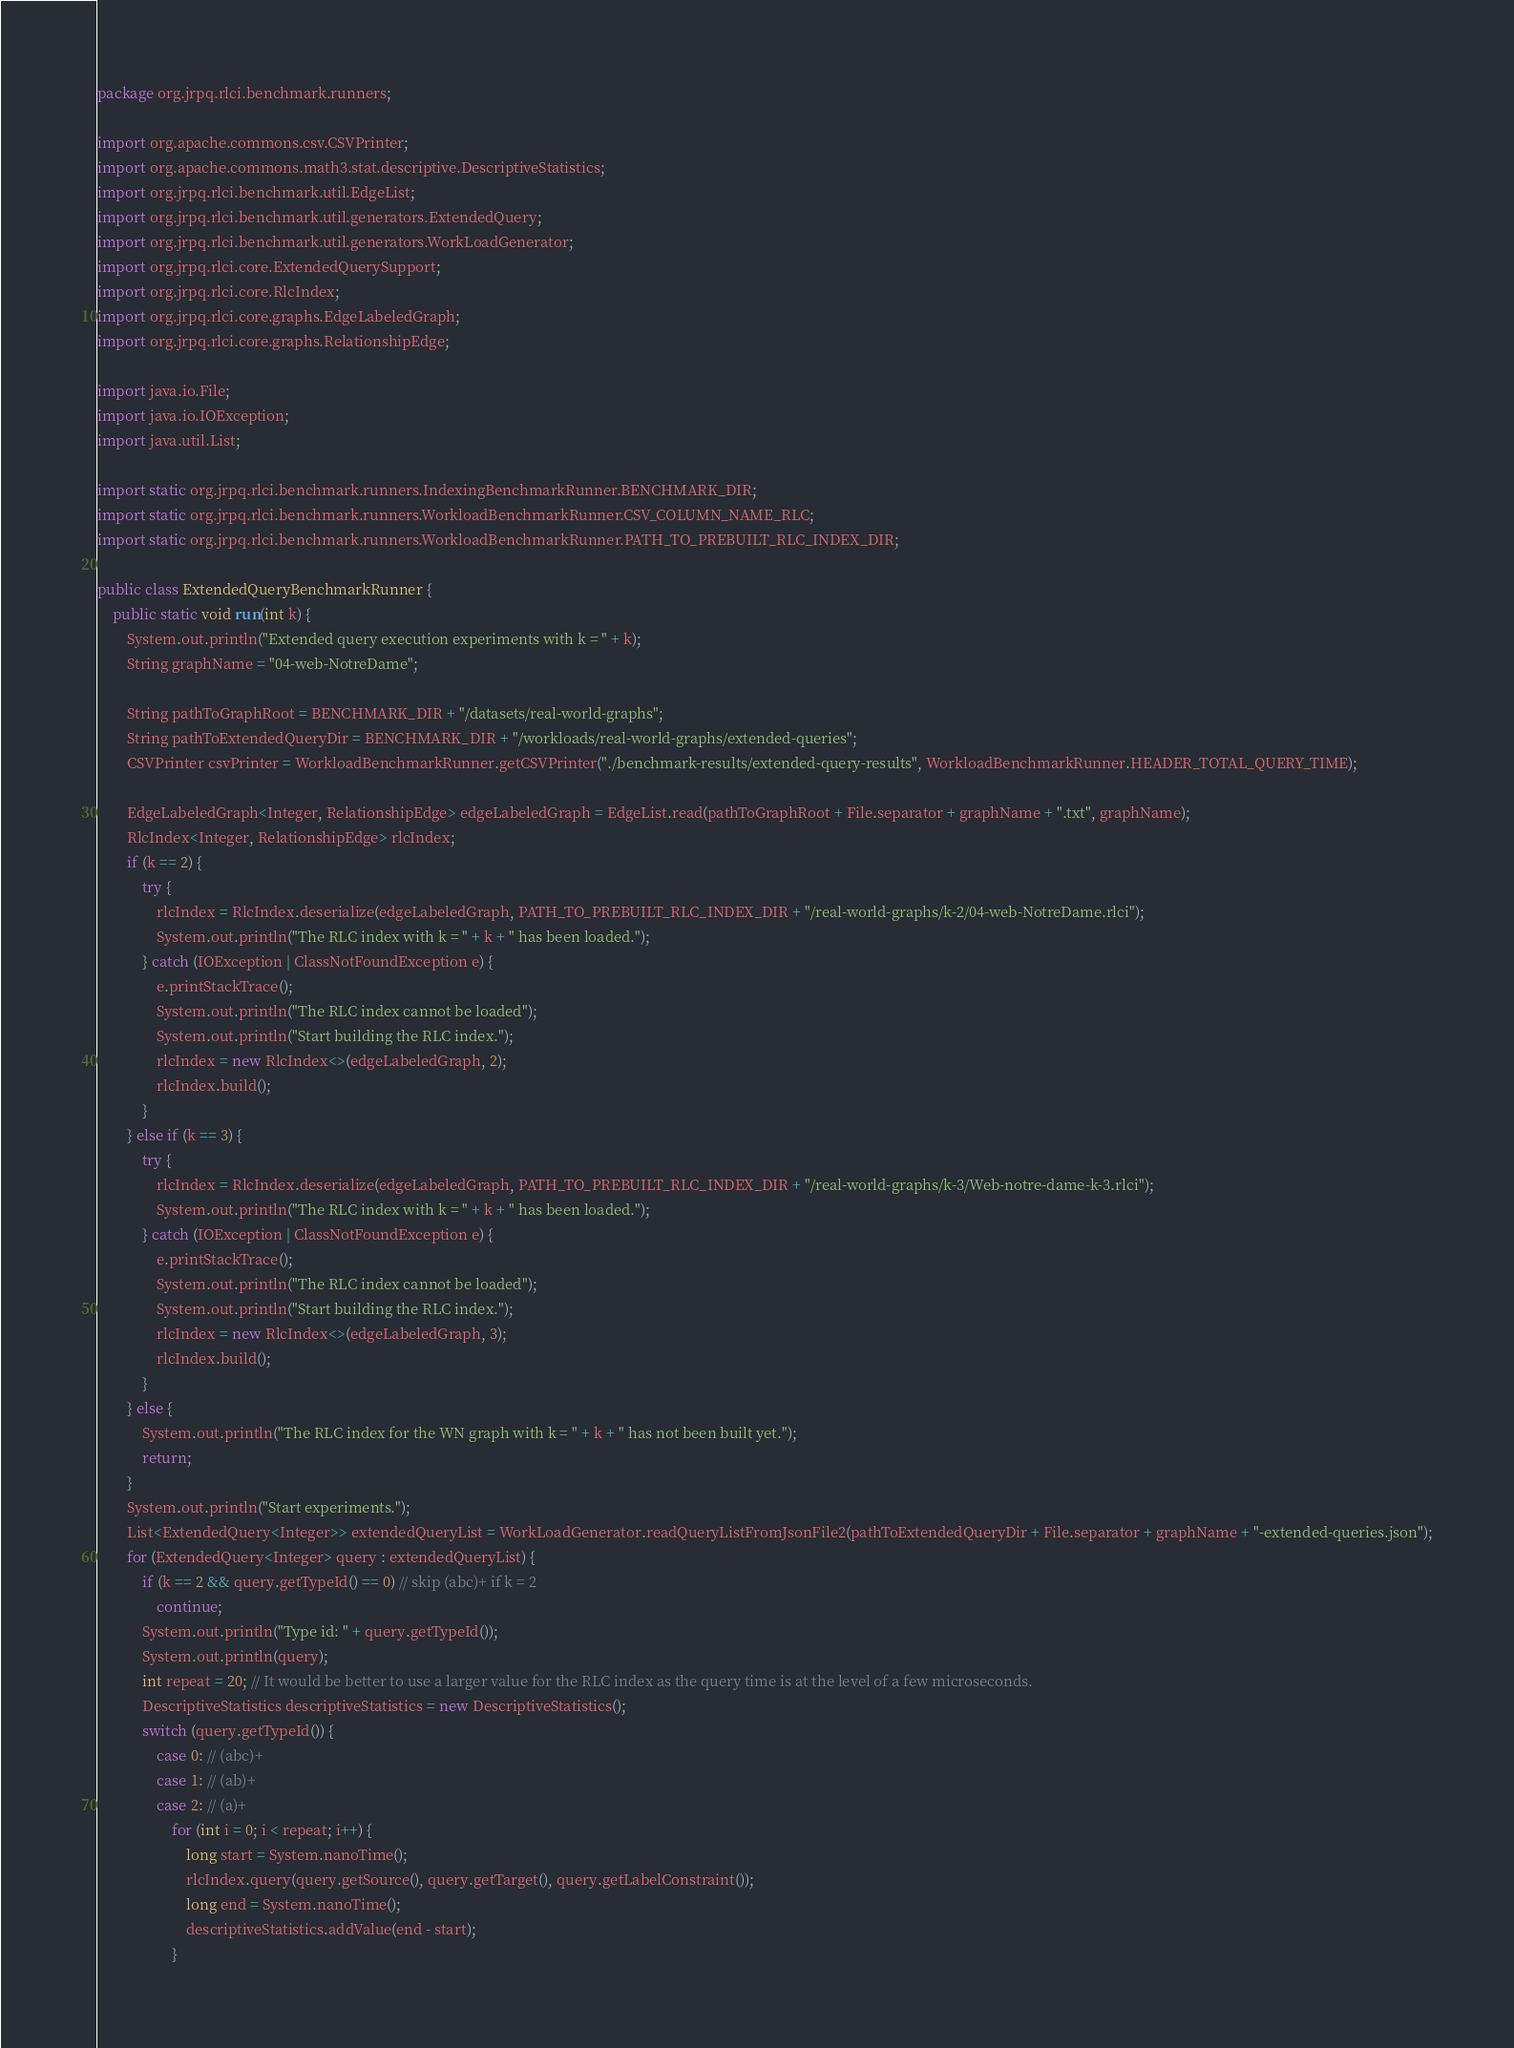<code> <loc_0><loc_0><loc_500><loc_500><_Java_>package org.jrpq.rlci.benchmark.runners;

import org.apache.commons.csv.CSVPrinter;
import org.apache.commons.math3.stat.descriptive.DescriptiveStatistics;
import org.jrpq.rlci.benchmark.util.EdgeList;
import org.jrpq.rlci.benchmark.util.generators.ExtendedQuery;
import org.jrpq.rlci.benchmark.util.generators.WorkLoadGenerator;
import org.jrpq.rlci.core.ExtendedQuerySupport;
import org.jrpq.rlci.core.RlcIndex;
import org.jrpq.rlci.core.graphs.EdgeLabeledGraph;
import org.jrpq.rlci.core.graphs.RelationshipEdge;

import java.io.File;
import java.io.IOException;
import java.util.List;

import static org.jrpq.rlci.benchmark.runners.IndexingBenchmarkRunner.BENCHMARK_DIR;
import static org.jrpq.rlci.benchmark.runners.WorkloadBenchmarkRunner.CSV_COLUMN_NAME_RLC;
import static org.jrpq.rlci.benchmark.runners.WorkloadBenchmarkRunner.PATH_TO_PREBUILT_RLC_INDEX_DIR;

public class ExtendedQueryBenchmarkRunner {
    public static void run(int k) {
        System.out.println("Extended query execution experiments with k = " + k);
        String graphName = "04-web-NotreDame";

        String pathToGraphRoot = BENCHMARK_DIR + "/datasets/real-world-graphs";
        String pathToExtendedQueryDir = BENCHMARK_DIR + "/workloads/real-world-graphs/extended-queries";
        CSVPrinter csvPrinter = WorkloadBenchmarkRunner.getCSVPrinter("./benchmark-results/extended-query-results", WorkloadBenchmarkRunner.HEADER_TOTAL_QUERY_TIME);

        EdgeLabeledGraph<Integer, RelationshipEdge> edgeLabeledGraph = EdgeList.read(pathToGraphRoot + File.separator + graphName + ".txt", graphName);
        RlcIndex<Integer, RelationshipEdge> rlcIndex;
        if (k == 2) {
            try {
                rlcIndex = RlcIndex.deserialize(edgeLabeledGraph, PATH_TO_PREBUILT_RLC_INDEX_DIR + "/real-world-graphs/k-2/04-web-NotreDame.rlci");
                System.out.println("The RLC index with k = " + k + " has been loaded.");
            } catch (IOException | ClassNotFoundException e) {
                e.printStackTrace();
                System.out.println("The RLC index cannot be loaded");
                System.out.println("Start building the RLC index.");
                rlcIndex = new RlcIndex<>(edgeLabeledGraph, 2);
                rlcIndex.build();
            }
        } else if (k == 3) {
            try {
                rlcIndex = RlcIndex.deserialize(edgeLabeledGraph, PATH_TO_PREBUILT_RLC_INDEX_DIR + "/real-world-graphs/k-3/Web-notre-dame-k-3.rlci");
                System.out.println("The RLC index with k = " + k + " has been loaded.");
            } catch (IOException | ClassNotFoundException e) {
                e.printStackTrace();
                System.out.println("The RLC index cannot be loaded");
                System.out.println("Start building the RLC index.");
                rlcIndex = new RlcIndex<>(edgeLabeledGraph, 3);
                rlcIndex.build();
            }
        } else {
            System.out.println("The RLC index for the WN graph with k = " + k + " has not been built yet.");
            return;
        }
        System.out.println("Start experiments.");
        List<ExtendedQuery<Integer>> extendedQueryList = WorkLoadGenerator.readQueryListFromJsonFile2(pathToExtendedQueryDir + File.separator + graphName + "-extended-queries.json");
        for (ExtendedQuery<Integer> query : extendedQueryList) {
            if (k == 2 && query.getTypeId() == 0) // skip (abc)+ if k = 2
                continue;
            System.out.println("Type id: " + query.getTypeId());
            System.out.println(query);
            int repeat = 20; // It would be better to use a larger value for the RLC index as the query time is at the level of a few microseconds.
            DescriptiveStatistics descriptiveStatistics = new DescriptiveStatistics();
            switch (query.getTypeId()) {
                case 0: // (abc)+
                case 1: // (ab)+
                case 2: // (a)+
                    for (int i = 0; i < repeat; i++) {
                        long start = System.nanoTime();
                        rlcIndex.query(query.getSource(), query.getTarget(), query.getLabelConstraint());
                        long end = System.nanoTime();
                        descriptiveStatistics.addValue(end - start);
                    }</code> 